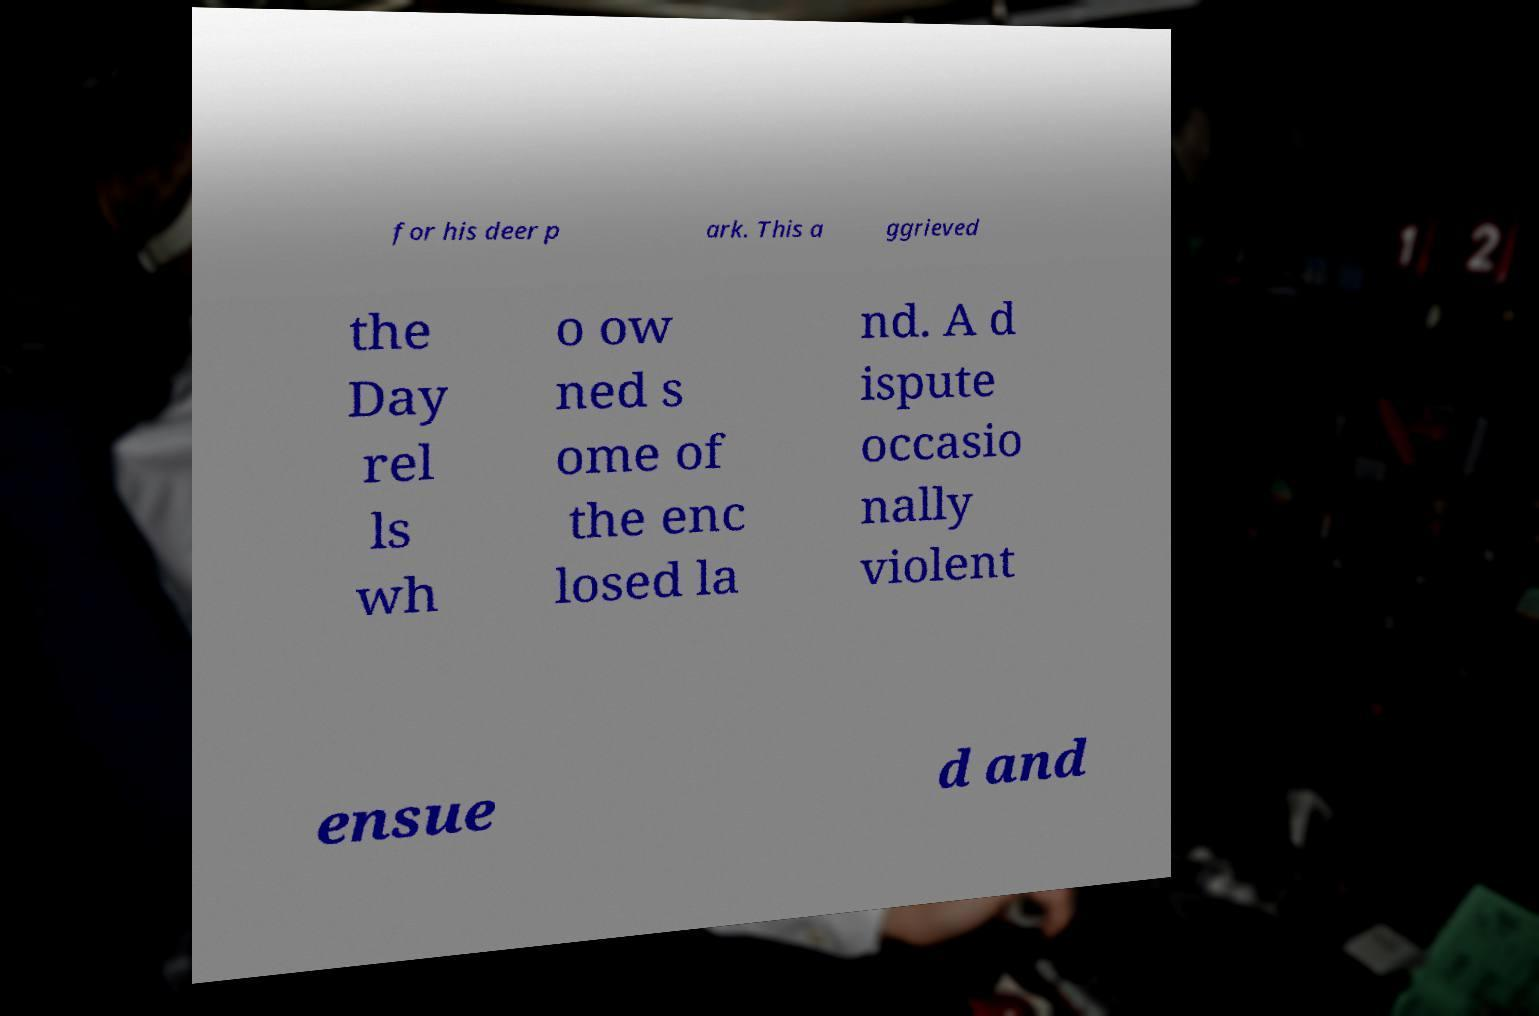Please identify and transcribe the text found in this image. for his deer p ark. This a ggrieved the Day rel ls wh o ow ned s ome of the enc losed la nd. A d ispute occasio nally violent ensue d and 